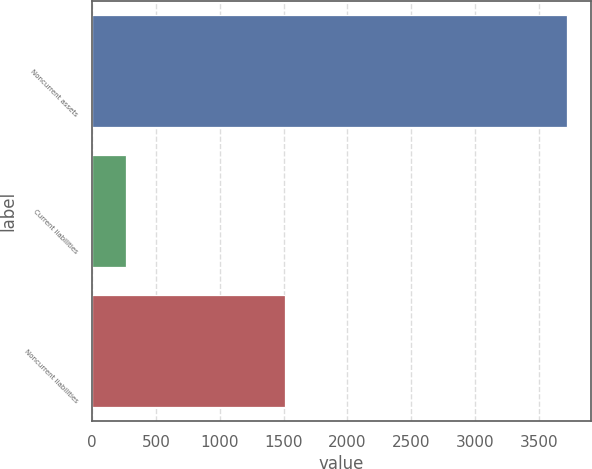Convert chart. <chart><loc_0><loc_0><loc_500><loc_500><bar_chart><fcel>Noncurrent assets<fcel>Current liabilities<fcel>Noncurrent liabilities<nl><fcel>3723<fcel>266<fcel>1511<nl></chart> 